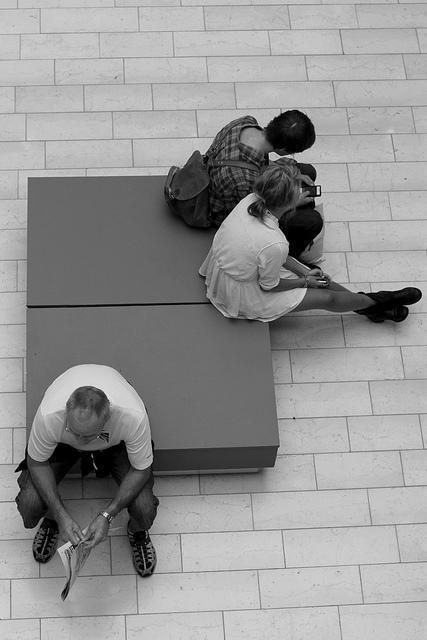How many men are in this picture?
Give a very brief answer. 1. How many people are there?
Give a very brief answer. 3. 